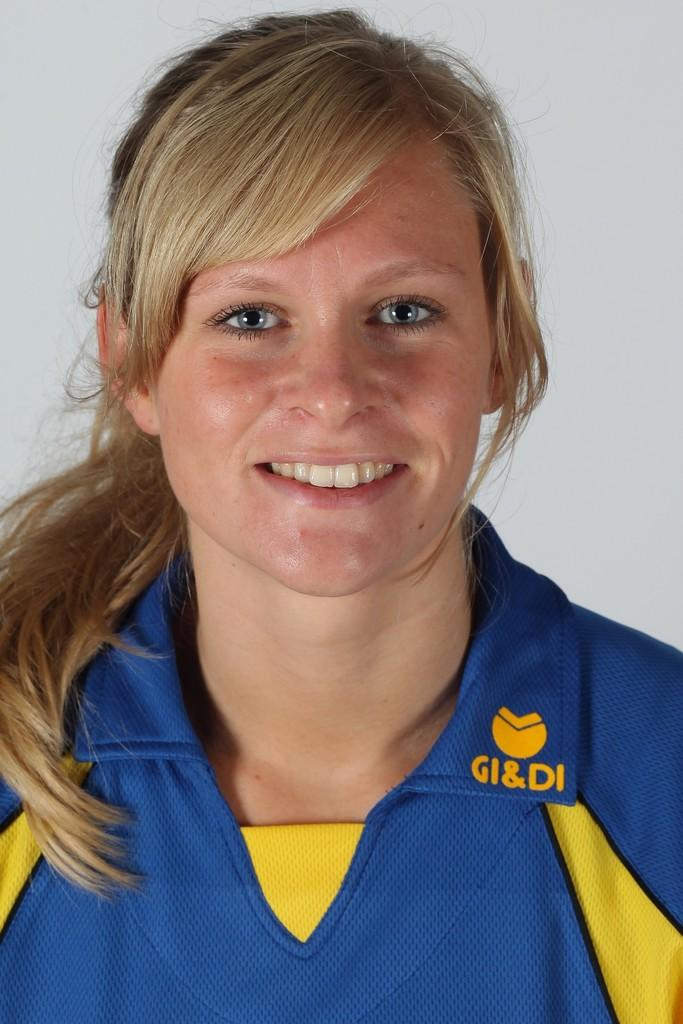<image>
Write a terse but informative summary of the picture. a girl with GI&DI on her shirt with a white wall behind 